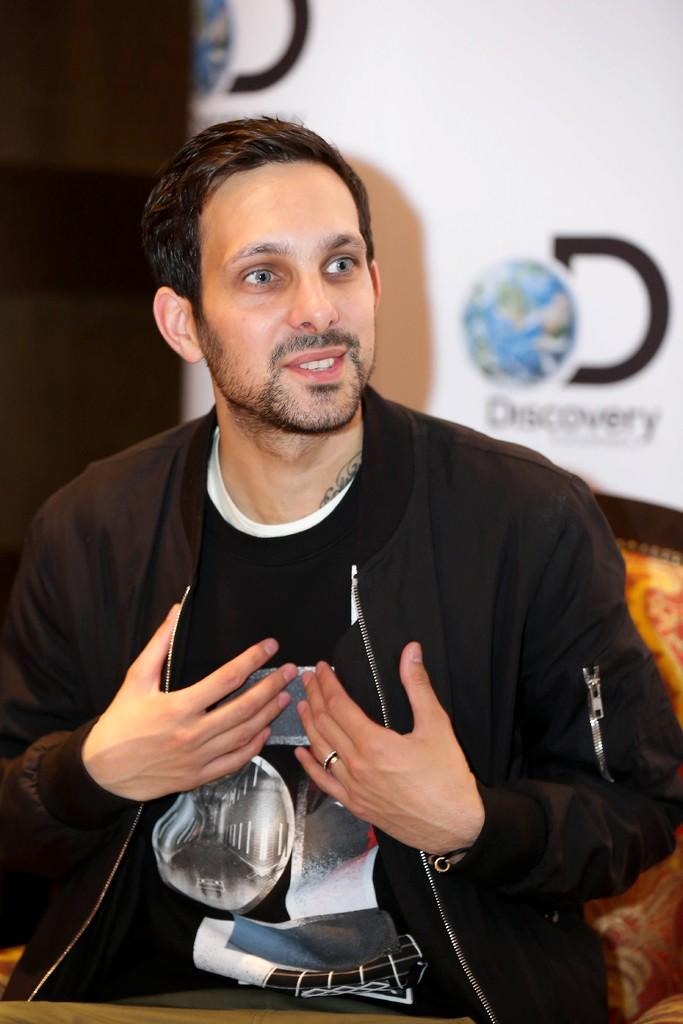What is the person in the image doing? The person is sitting in the image. What is the person wearing? The person is wearing a black dress. What can be seen in the background of the image? There is a white-colored board in the background of the image. What type of wall is the person arguing against in the image? There is no wall or argument present in the image; it only shows a person sitting in a black dress with a white-colored board in the background. 